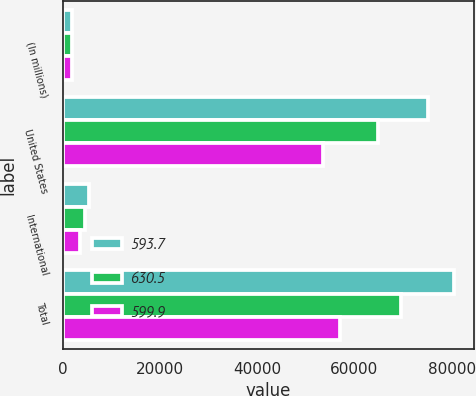Convert chart. <chart><loc_0><loc_0><loc_500><loc_500><stacked_bar_chart><ecel><fcel>(In millions)<fcel>United States<fcel>International<fcel>Total<nl><fcel>593.7<fcel>2005<fcel>75102.6<fcel>5412<fcel>80514.6<nl><fcel>630.5<fcel>2004<fcel>64856.7<fcel>4649.4<fcel>69506.1<nl><fcel>599.9<fcel>2003<fcel>53544.8<fcel>3576<fcel>57120.8<nl></chart> 